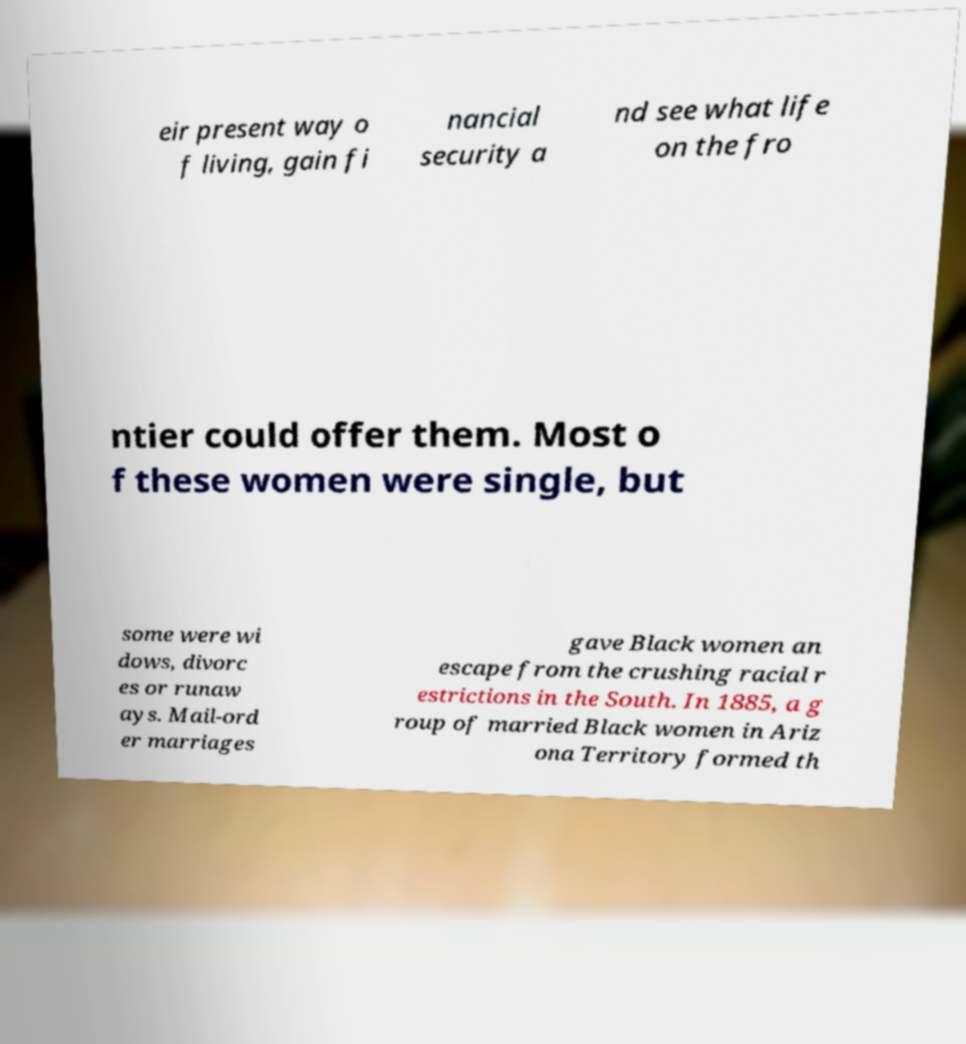There's text embedded in this image that I need extracted. Can you transcribe it verbatim? eir present way o f living, gain fi nancial security a nd see what life on the fro ntier could offer them. Most o f these women were single, but some were wi dows, divorc es or runaw ays. Mail-ord er marriages gave Black women an escape from the crushing racial r estrictions in the South. In 1885, a g roup of married Black women in Ariz ona Territory formed th 